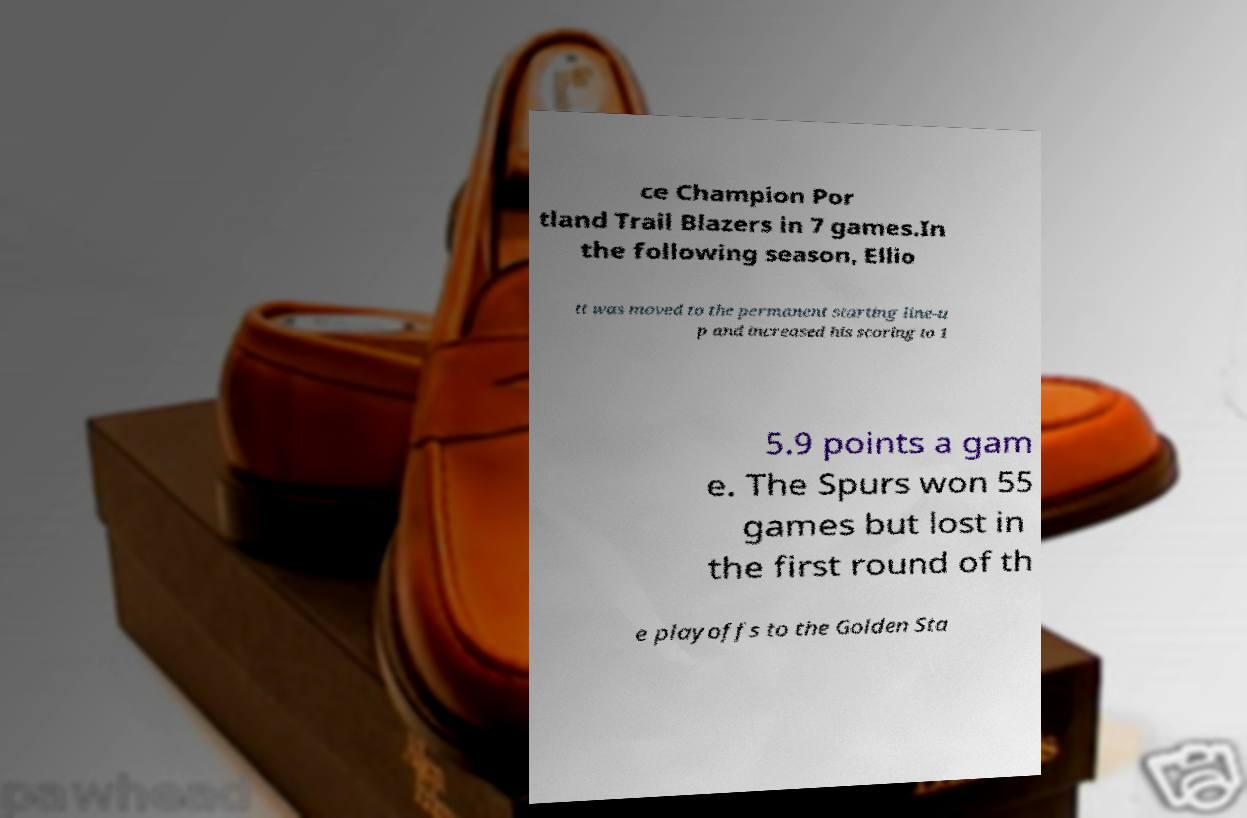I need the written content from this picture converted into text. Can you do that? ce Champion Por tland Trail Blazers in 7 games.In the following season, Ellio tt was moved to the permanent starting line-u p and increased his scoring to 1 5.9 points a gam e. The Spurs won 55 games but lost in the first round of th e playoffs to the Golden Sta 